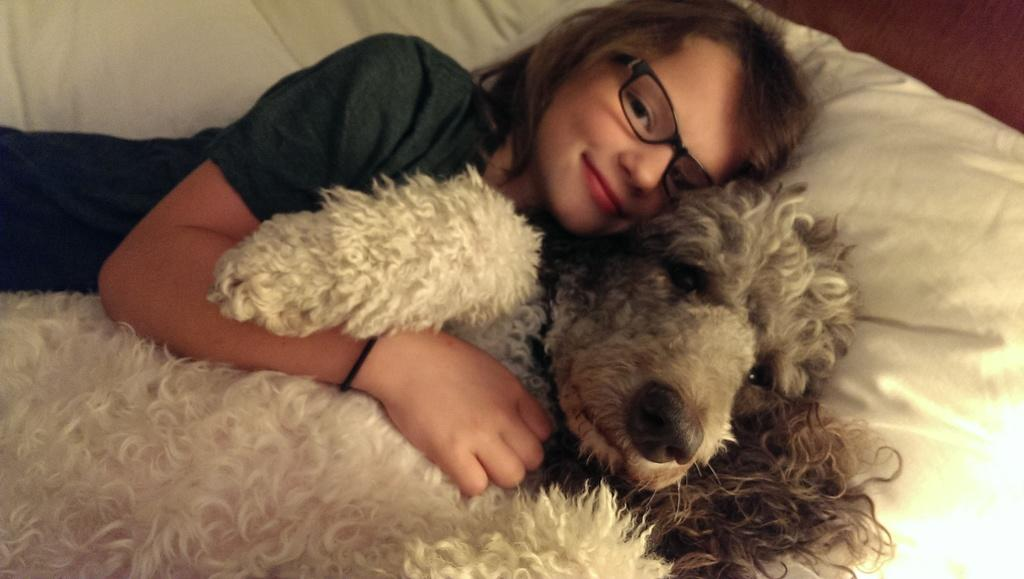Who is the main subject in the picture? There is a girl in the picture. What is the girl wearing? The girl is wearing spectacles. What is the girl's position in the picture? The girl is lying on the bed. Are there any animals in the picture? Yes, there is a dog in the picture. What is the dog doing in the picture? The dog is lying on the bed. What is the girl's expression in the picture? The girl is smiling. What type of trouble is the girl causing with the trucks in the picture? There are no trucks present in the image, so it is not possible to determine if the girl is causing any trouble with them. 